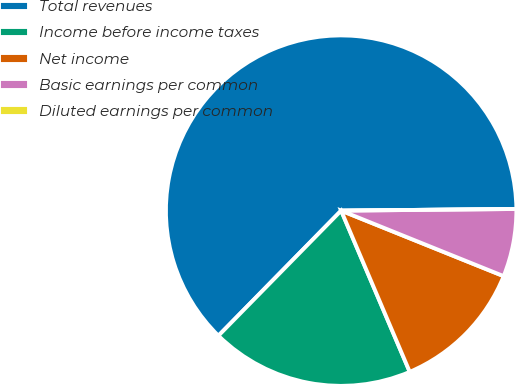<chart> <loc_0><loc_0><loc_500><loc_500><pie_chart><fcel>Total revenues<fcel>Income before income taxes<fcel>Net income<fcel>Basic earnings per common<fcel>Diluted earnings per common<nl><fcel>62.5%<fcel>18.75%<fcel>12.5%<fcel>6.25%<fcel>0.0%<nl></chart> 